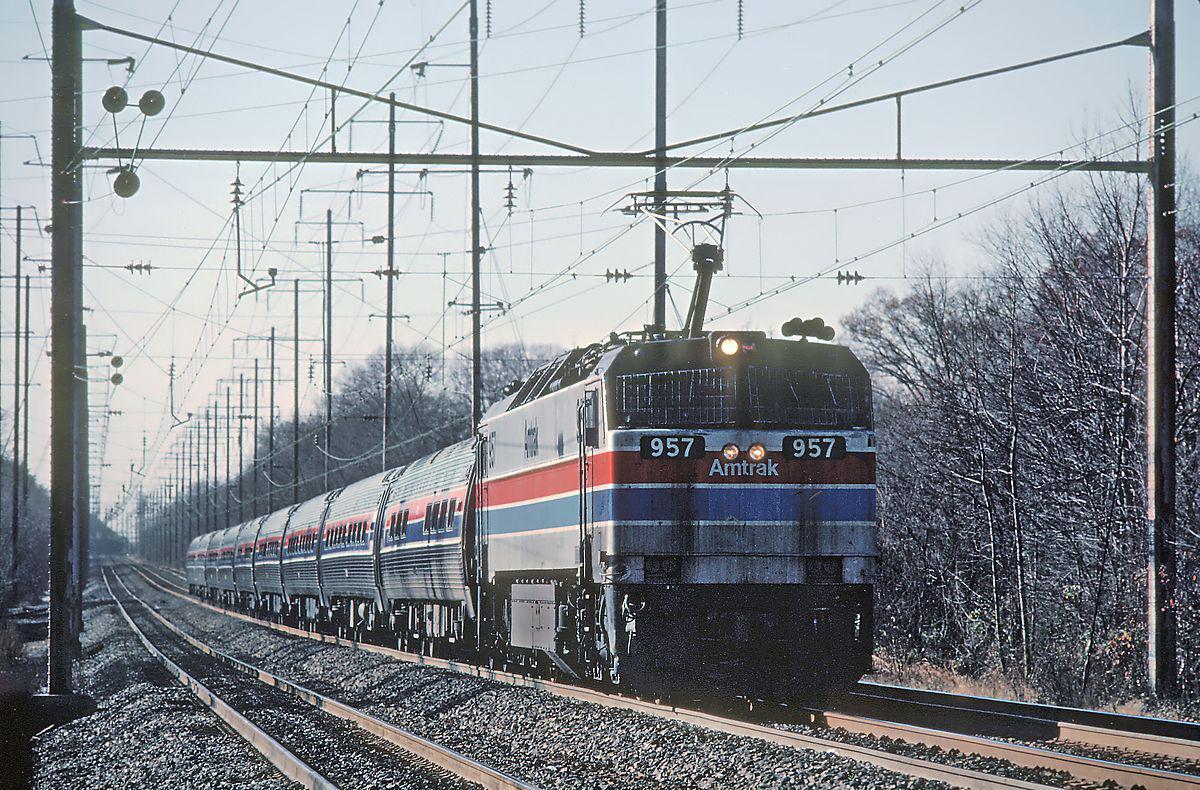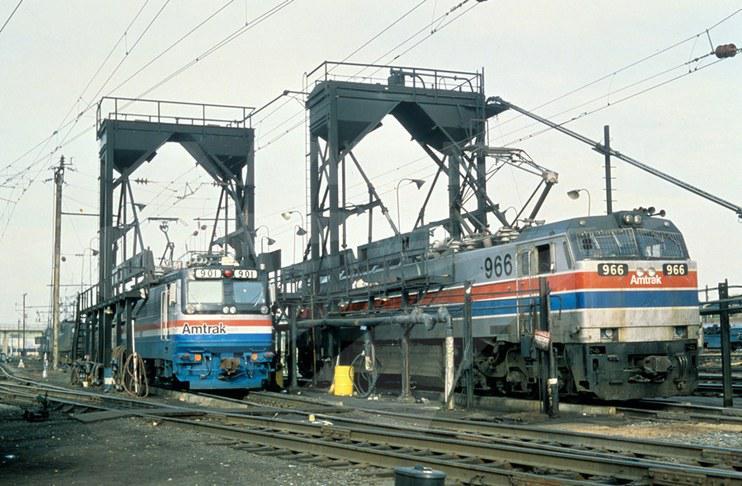The first image is the image on the left, the second image is the image on the right. Considering the images on both sides, is "Each train is headed in the same direction." valid? Answer yes or no. Yes. The first image is the image on the left, the second image is the image on the right. Examine the images to the left and right. Is the description "At least one train has a flat front and blue and red stripes outlined in white running the length of the sides." accurate? Answer yes or no. Yes. 